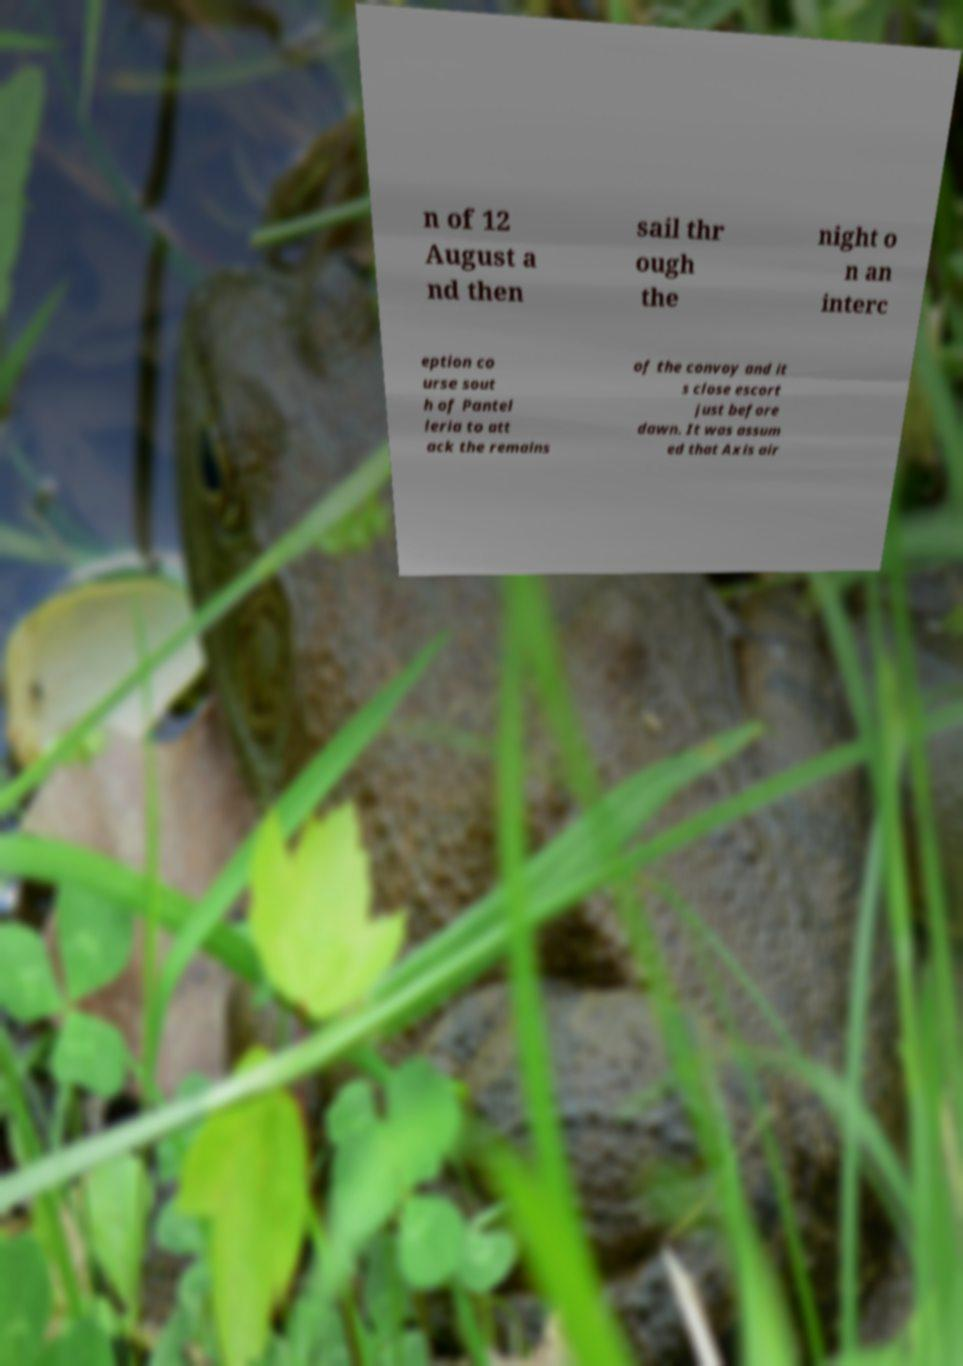For documentation purposes, I need the text within this image transcribed. Could you provide that? n of 12 August a nd then sail thr ough the night o n an interc eption co urse sout h of Pantel leria to att ack the remains of the convoy and it s close escort just before dawn. It was assum ed that Axis air 